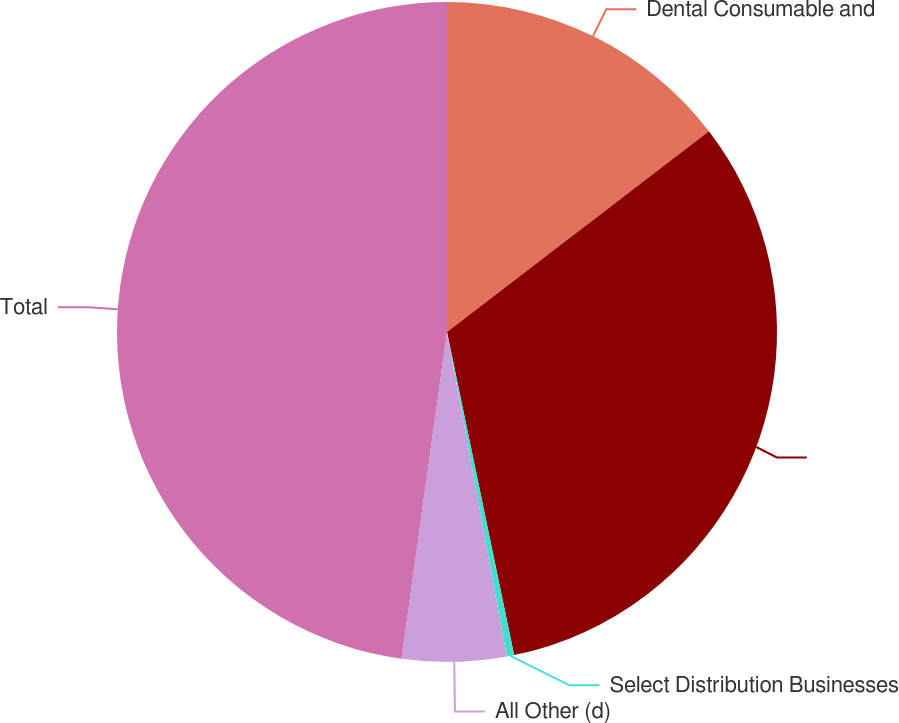<chart> <loc_0><loc_0><loc_500><loc_500><pie_chart><fcel>Dental Consumable and<fcel>Unnamed: 1<fcel>Select Distribution Businesses<fcel>All Other (d)<fcel>Total<nl><fcel>14.59%<fcel>32.15%<fcel>0.36%<fcel>5.1%<fcel>47.8%<nl></chart> 